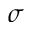Convert formula to latex. <formula><loc_0><loc_0><loc_500><loc_500>\sigma</formula> 